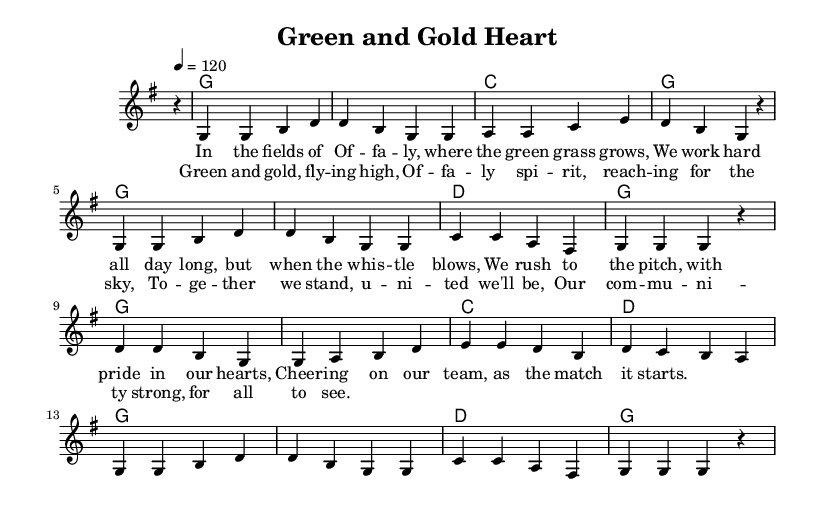What is the key signature of this music? The key signature indicated in the global section of the code is G major, which contains one sharp (F#). This is often represented by the symbol on the staff at the beginning of the sheet music.
Answer: G major What is the time signature of this piece? The time signature shown in the global section is 4/4, meaning there are four beats per measure and a quarter note gets one beat. This is standard and is typically found at the start of the piece.
Answer: 4/4 What is the tempo marking given? The tempo is indicated as "4 = 120", which means there are 120 beats per minute, determined by looking at the tempo marking directly stated in the global section.
Answer: 120 How many measures are in the verse section? Counting the measures of music notated before the chorus, there are a total of 8 measures stated in the melody section for the verse, which can be identified by looking at the number of bar lines.
Answer: 8 What is the primary emotion conveyed in the lyrics? The lyrics suggest a strong sense of community and pride, as indicated by phrases like "We work hard all day long" and "Cheering on our team." This conveys a feeling of unity and support for the local sports team, emphasizing local pride.
Answer: Pride Which colors are associated with the local sports team in the song? The colors mentioned in the chorus are "green and gold," which signifies the team colors as celebrated in the anthem, reflecting the community spirit and local pride.
Answer: Green and gold What is the overall theme of the song? The overarching theme is community spirit, as expressed through the lyrics celebrating local sports and the unity of the people of Offaly. This is evident from lines that emphasize togetherness and local identity.
Answer: Community spirit 